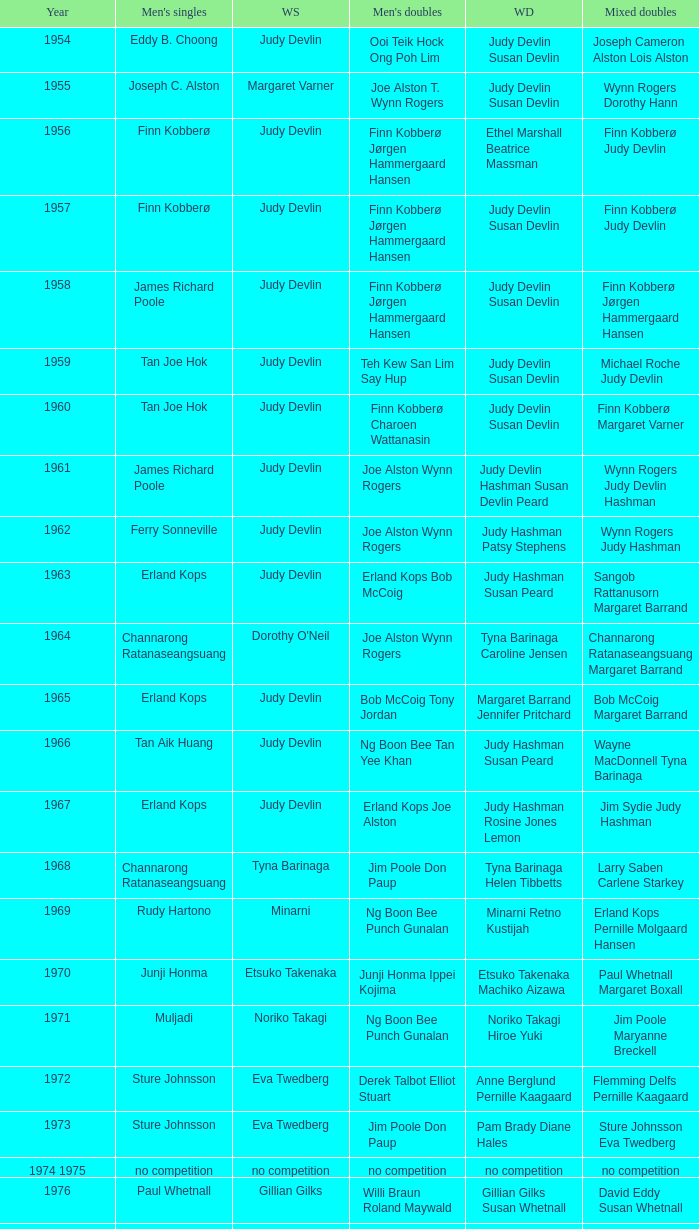Who were the men's doubles champions when the men's singles champion was muljadi? Ng Boon Bee Punch Gunalan. Could you parse the entire table as a dict? {'header': ['Year', "Men's singles", 'WS', "Men's doubles", 'WD', 'Mixed doubles'], 'rows': [['1954', 'Eddy B. Choong', 'Judy Devlin', 'Ooi Teik Hock Ong Poh Lim', 'Judy Devlin Susan Devlin', 'Joseph Cameron Alston Lois Alston'], ['1955', 'Joseph C. Alston', 'Margaret Varner', 'Joe Alston T. Wynn Rogers', 'Judy Devlin Susan Devlin', 'Wynn Rogers Dorothy Hann'], ['1956', 'Finn Kobberø', 'Judy Devlin', 'Finn Kobberø Jørgen Hammergaard Hansen', 'Ethel Marshall Beatrice Massman', 'Finn Kobberø Judy Devlin'], ['1957', 'Finn Kobberø', 'Judy Devlin', 'Finn Kobberø Jørgen Hammergaard Hansen', 'Judy Devlin Susan Devlin', 'Finn Kobberø Judy Devlin'], ['1958', 'James Richard Poole', 'Judy Devlin', 'Finn Kobberø Jørgen Hammergaard Hansen', 'Judy Devlin Susan Devlin', 'Finn Kobberø Jørgen Hammergaard Hansen'], ['1959', 'Tan Joe Hok', 'Judy Devlin', 'Teh Kew San Lim Say Hup', 'Judy Devlin Susan Devlin', 'Michael Roche Judy Devlin'], ['1960', 'Tan Joe Hok', 'Judy Devlin', 'Finn Kobberø Charoen Wattanasin', 'Judy Devlin Susan Devlin', 'Finn Kobberø Margaret Varner'], ['1961', 'James Richard Poole', 'Judy Devlin', 'Joe Alston Wynn Rogers', 'Judy Devlin Hashman Susan Devlin Peard', 'Wynn Rogers Judy Devlin Hashman'], ['1962', 'Ferry Sonneville', 'Judy Devlin', 'Joe Alston Wynn Rogers', 'Judy Hashman Patsy Stephens', 'Wynn Rogers Judy Hashman'], ['1963', 'Erland Kops', 'Judy Devlin', 'Erland Kops Bob McCoig', 'Judy Hashman Susan Peard', 'Sangob Rattanusorn Margaret Barrand'], ['1964', 'Channarong Ratanaseangsuang', "Dorothy O'Neil", 'Joe Alston Wynn Rogers', 'Tyna Barinaga Caroline Jensen', 'Channarong Ratanaseangsuang Margaret Barrand'], ['1965', 'Erland Kops', 'Judy Devlin', 'Bob McCoig Tony Jordan', 'Margaret Barrand Jennifer Pritchard', 'Bob McCoig Margaret Barrand'], ['1966', 'Tan Aik Huang', 'Judy Devlin', 'Ng Boon Bee Tan Yee Khan', 'Judy Hashman Susan Peard', 'Wayne MacDonnell Tyna Barinaga'], ['1967', 'Erland Kops', 'Judy Devlin', 'Erland Kops Joe Alston', 'Judy Hashman Rosine Jones Lemon', 'Jim Sydie Judy Hashman'], ['1968', 'Channarong Ratanaseangsuang', 'Tyna Barinaga', 'Jim Poole Don Paup', 'Tyna Barinaga Helen Tibbetts', 'Larry Saben Carlene Starkey'], ['1969', 'Rudy Hartono', 'Minarni', 'Ng Boon Bee Punch Gunalan', 'Minarni Retno Kustijah', 'Erland Kops Pernille Molgaard Hansen'], ['1970', 'Junji Honma', 'Etsuko Takenaka', 'Junji Honma Ippei Kojima', 'Etsuko Takenaka Machiko Aizawa', 'Paul Whetnall Margaret Boxall'], ['1971', 'Muljadi', 'Noriko Takagi', 'Ng Boon Bee Punch Gunalan', 'Noriko Takagi Hiroe Yuki', 'Jim Poole Maryanne Breckell'], ['1972', 'Sture Johnsson', 'Eva Twedberg', 'Derek Talbot Elliot Stuart', 'Anne Berglund Pernille Kaagaard', 'Flemming Delfs Pernille Kaagaard'], ['1973', 'Sture Johnsson', 'Eva Twedberg', 'Jim Poole Don Paup', 'Pam Brady Diane Hales', 'Sture Johnsson Eva Twedberg'], ['1974 1975', 'no competition', 'no competition', 'no competition', 'no competition', 'no competition'], ['1976', 'Paul Whetnall', 'Gillian Gilks', 'Willi Braun Roland Maywald', 'Gillian Gilks Susan Whetnall', 'David Eddy Susan Whetnall'], ['1977 1982', 'no competition', 'no competition', 'no competition', 'no competition', 'no competition'], ['1983', 'Mike Butler', 'Sherrie Liu', 'John Britton Gary Higgins', 'Claire Backhouse Johanne Falardeau', 'Mike Butler Claire Backhouse'], ['1984', 'Xiong Guobao', 'Luo Yun', 'Chen Hongyong Zhang Qingwu', 'Yin Haichen Lu Yanahua', 'Wang Pengren Luo Yun'], ['1985', 'Mike Butler', 'Claire Backhouse Sharpe', 'John Britton Gary Higgins', 'Claire Sharpe Sandra Skillings', 'Mike Butler Claire Sharpe'], ['1986', 'Sung Han-kuk', 'Denyse Julien', 'Yao Ximing Tariq Wadood', 'Denyse Julien Johanne Falardeau', 'Mike Butler Johanne Falardeau'], ['1987', 'Park Sun-bae', 'Chun Suk-sun', 'Lee Deuk-choon Lee Sang-bok', 'Kim Ho Ja Chung So-young', 'Lee Deuk-choon Chung So-young'], ['1988', 'Sze Yu', 'Lee Myeong-hee', 'Christian Hadinata Lius Pongoh', 'Kim Ho Ja Chung So-young', 'Christian Hadinata Ivana Lie'], ['1989', 'no competition', 'no competition', 'no competition', 'no competition', 'no competition'], ['1990', 'Fung Permadi', 'Denyse Julien', 'Ger Shin-Ming Yang Shih-Jeng', 'Denyse Julien Doris Piché', 'Tariq Wadood Traci Britton'], ['1991', 'Steve Butler', 'Shim Eun-jung', 'Jalani Sidek Razif Sidek', 'Shim Eun-jung Kang Bok-seung', 'Lee Sang-bok Shim Eun-jung'], ['1992', 'Poul-Erik Hoyer-Larsen', 'Lim Xiaoqing', 'Cheah Soon Kit Soo Beng Kiang', 'Lim Xiaoqing Christine Magnusson', 'Thomas Lund Pernille Dupont'], ['1993', 'Marleve Mainaky', 'Lim Xiaoqing', 'Thomas Lund Jon Holst-Christensen', 'Gil Young-ah Chung So-young', 'Thomas Lund Catrine Bengtsson'], ['1994', 'Thomas Stuer-Lauridsen', 'Liu Guimei', 'Ade Sutrisna Candra Wijaya', 'Rikke Olsen Helene Kirkegaard', 'Jens Eriksen Rikke Olsen'], ['1995', 'Hermawan Susanto', 'Ye Zhaoying', 'Rudy Gunawan Joko Suprianto', 'Gil Young-ah Jang Hye-ock', 'Kim Dong-moon Gil Young-ah'], ['1996', 'Joko Suprianto', 'Mia Audina', 'Candra Wijaya Sigit Budiarto', 'Zelin Resiana Eliza Nathanael', 'Kim Dong-moon Chung So-young'], ['1997', 'Poul-Erik Hoyer-Larsen', 'Camilla Martin', 'Ha Tae-kwon Kim Dong-moon', 'Qin Yiyuan Tang Yongshu', 'Kim Dong Moon Ra Kyung-min'], ['1998', 'Fung Permadi', 'Tang Yeping', 'Horng Shin-Jeng Lee Wei-Jen', 'Elinor Middlemiss Kirsteen McEwan', 'Kenny Middlemiss Elinor Middlemiss'], ['1999', 'Colin Haughton', 'Pi Hongyan', 'Michael Lamp Jonas Rasmussen', 'Huang Nanyan Lu Ying', 'Jonas Rasmussen Jane F. Bramsen'], ['2000', 'Ardy Wiranata', 'Choi Ma-re', 'Graham Hurrell James Anderson', 'Gail Emms Joanne Wright', 'Jonas Rasmussen Jane F. Bramsen'], ['2001', 'Lee Hyun-il', 'Ra Kyung-min', 'Kang Kyung-jin Park Young-duk', 'Kim Kyeung-ran Ra Kyung-min', 'Mathias Boe Majken Vange'], ['2002', 'Peter Gade', 'Julia Mann', 'Tony Gunawan Khan Malaythong', 'Joanne Wright Natalie Munt', 'Tony Gunawan Etty Tantri'], ['2003', 'Chien Yu-hsiu', 'Kelly Morgan', 'Tony Gunawan Khan Malaythong', 'Yoshiko Iwata Miyuki Tai', 'Tony Gunawan Eti Gunawan'], ['2004', 'Kendrick Lee Yen Hui', 'Xing Aiying', 'Howard Bach Tony Gunawan', 'Cheng Wen-hsing Chien Yu-chin', 'Lin Wei-hsiang Cheng Wen-hsing'], ['2005', 'Hsieh Yu-hsing', 'Lili Zhou', 'Howard Bach Tony Gunawan', 'Peng Yun Johanna Lee', 'Khan Malaythong Mesinee Mangkalakiri'], ['2006', 'Yousuke Nakanishi', 'Ella Karachkova', 'Halim Haryanto Tony Gunawan', 'Nina Vislova Valeria Sorokina', 'Sergey Ivlev Nina Vislova'], ['2007', 'Lee Tsuen Seng', 'Jun Jae-youn', 'Tadashi Ohtsuka Keita Masuda', 'Miyuki Maeda Satoko Suetsuna', 'Keita Masuda Miyuki Maeda'], ['2008', 'Andrew Dabeka', 'Lili Zhou', 'Howard Bach Khan Malaythong', 'Chang Li-Ying Hung Shih-Chieh', 'Halim Haryanto Peng Yun'], ['2009', 'Taufik Hidayat', 'Anna Rice', 'Howard Bach Tony Gunawan', 'Ruilin Huang Xuelian Jiang', 'Howard Bach Eva Lee'], ['2010', 'Rajiv Ouseph', 'Zhu Lin', 'Fang Chieh-min Lee Sheng-mu', 'Cheng Wen-hsing Chien Yu-chin', 'Michael Fuchs Birgit Overzier'], ['2011', 'Sho Sasaki', 'Tai Tzu-ying', 'Ko Sung-hyun Lee Yong-dae', 'Ha Jung-eun Kim Min-jung', 'Lee Yong-dae Ha Jung-eun'], ['2012', 'Vladimir Ivanov', 'Pai Hsiao-ma', 'Hiroyuki Endo Kenichi Hayakawa', 'Misaki Matsutomo Ayaka Takahashi', 'Tony Gunawan Vita Marissa'], ['2013', 'Nguyen Tien Minh', 'Sapsiree Taerattanachai', 'Takeshi Kamura Keigo Sonoda', 'Bao Yixin Zhong Qianxin', 'Lee Chun Hei Chau Hoi Wah']]} 